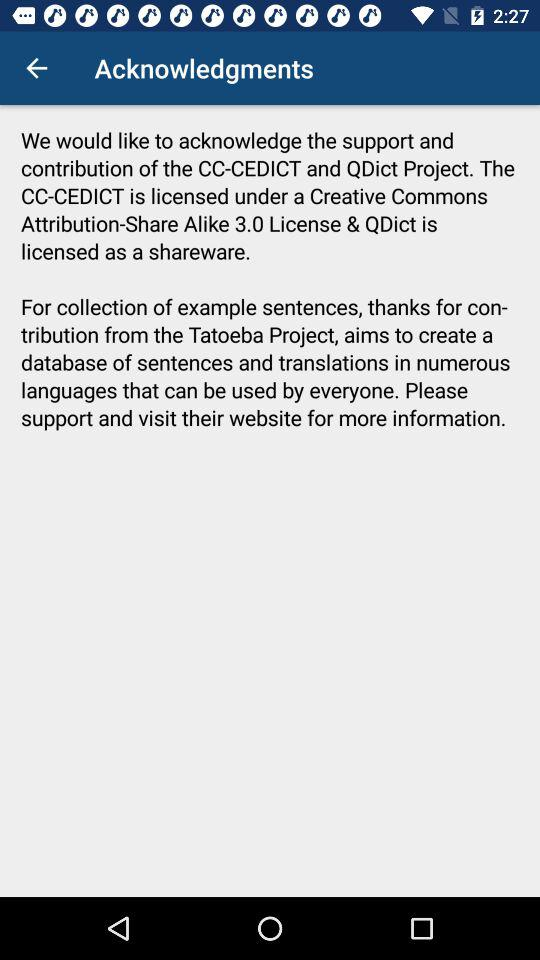How many acknowledgments are there?
Answer the question using a single word or phrase. 2 